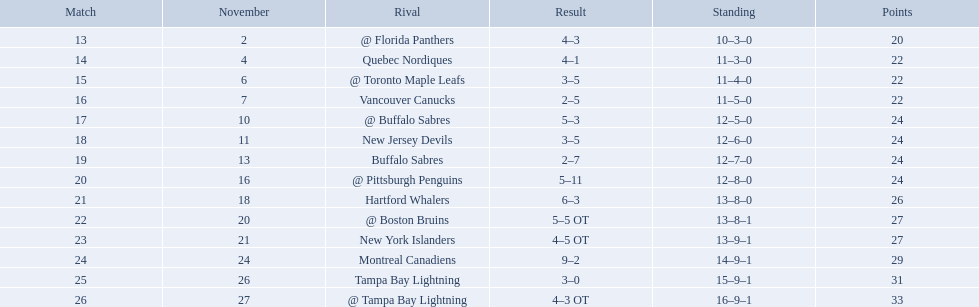Which teams scored 35 points or more in total? Hartford Whalers, @ Boston Bruins, New York Islanders, Montreal Canadiens, Tampa Bay Lightning, @ Tampa Bay Lightning. Of those teams, which team was the only one to score 3-0? Tampa Bay Lightning. What were the scores of the 1993-94 philadelphia flyers season? 4–3, 4–1, 3–5, 2–5, 5–3, 3–5, 2–7, 5–11, 6–3, 5–5 OT, 4–5 OT, 9–2, 3–0, 4–3 OT. Which of these teams had the score 4-5 ot? New York Islanders. 